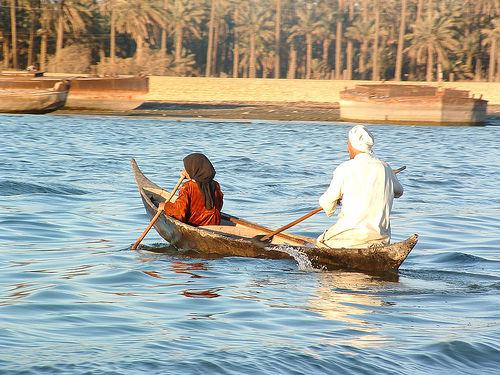Question: who is in the back of the boat?
Choices:
A. A man.
B. A girl.
C. A dog.
D. Grandma.
Answer with the letter. Answer: A Question: who is in the front of the boat?
Choices:
A. A man.
B. A child.
C. A woman.
D. Jerry.
Answer with the letter. Answer: C Question: what do the people have in their hands?
Choices:
A. Phones.
B. Drinks.
C. Brushes.
D. Oars.
Answer with the letter. Answer: D Question: where are the people seated?
Choices:
A. In a car.
B. On a couch.
C. In a canoe.
D. On the bed.
Answer with the letter. Answer: C Question: why are the people rowing?
Choices:
A. To move the boat.
B. To go down the river.
C. To win the race.
D. For fun.
Answer with the letter. Answer: A 